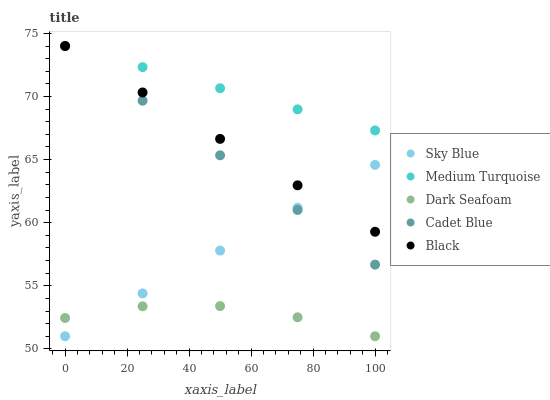Does Dark Seafoam have the minimum area under the curve?
Answer yes or no. Yes. Does Medium Turquoise have the maximum area under the curve?
Answer yes or no. Yes. Does Cadet Blue have the minimum area under the curve?
Answer yes or no. No. Does Cadet Blue have the maximum area under the curve?
Answer yes or no. No. Is Sky Blue the smoothest?
Answer yes or no. Yes. Is Dark Seafoam the roughest?
Answer yes or no. Yes. Is Cadet Blue the smoothest?
Answer yes or no. No. Is Cadet Blue the roughest?
Answer yes or no. No. Does Sky Blue have the lowest value?
Answer yes or no. Yes. Does Cadet Blue have the lowest value?
Answer yes or no. No. Does Medium Turquoise have the highest value?
Answer yes or no. Yes. Does Dark Seafoam have the highest value?
Answer yes or no. No. Is Dark Seafoam less than Black?
Answer yes or no. Yes. Is Medium Turquoise greater than Dark Seafoam?
Answer yes or no. Yes. Does Cadet Blue intersect Black?
Answer yes or no. Yes. Is Cadet Blue less than Black?
Answer yes or no. No. Is Cadet Blue greater than Black?
Answer yes or no. No. Does Dark Seafoam intersect Black?
Answer yes or no. No. 